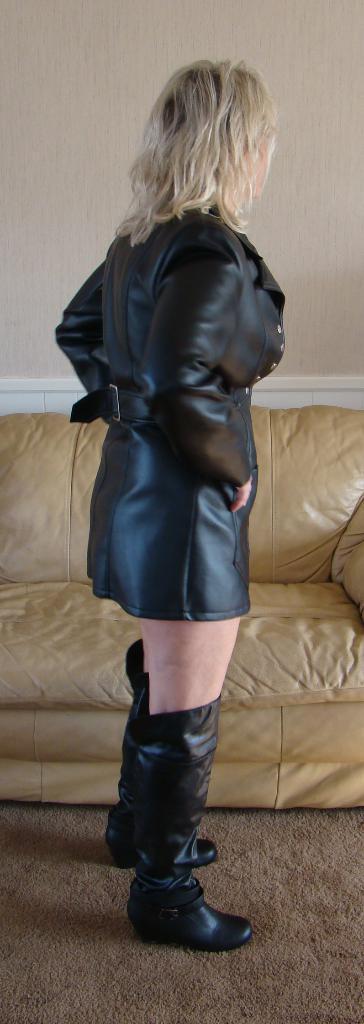In one or two sentences, can you explain what this image depicts? In this image we can see a woman standing and wearing a black dress and we can see a couch and there is a wall in the background. 